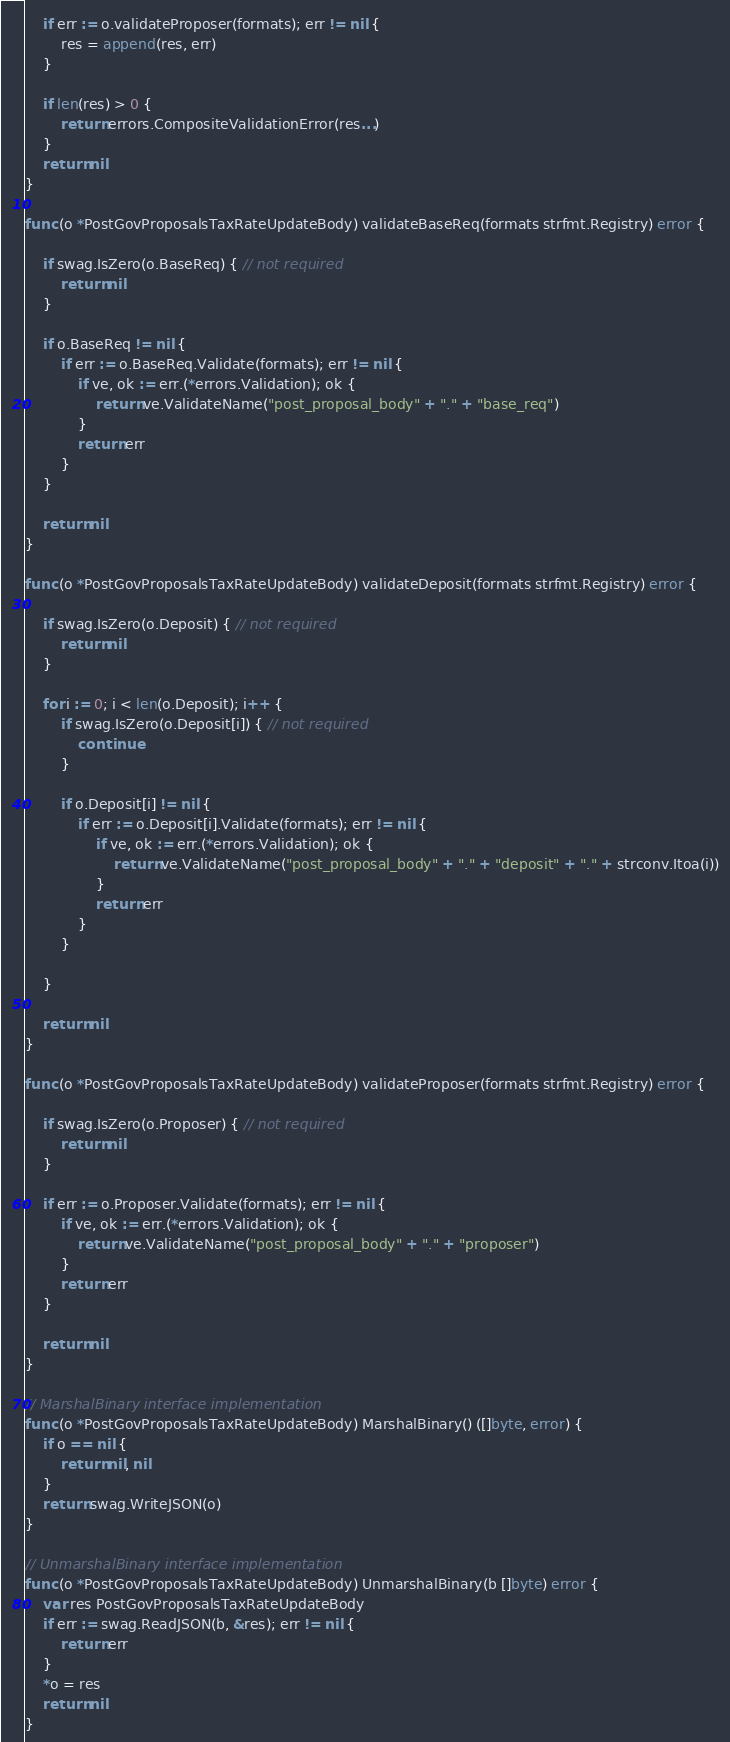<code> <loc_0><loc_0><loc_500><loc_500><_Go_>
	if err := o.validateProposer(formats); err != nil {
		res = append(res, err)
	}

	if len(res) > 0 {
		return errors.CompositeValidationError(res...)
	}
	return nil
}

func (o *PostGovProposalsTaxRateUpdateBody) validateBaseReq(formats strfmt.Registry) error {

	if swag.IsZero(o.BaseReq) { // not required
		return nil
	}

	if o.BaseReq != nil {
		if err := o.BaseReq.Validate(formats); err != nil {
			if ve, ok := err.(*errors.Validation); ok {
				return ve.ValidateName("post_proposal_body" + "." + "base_req")
			}
			return err
		}
	}

	return nil
}

func (o *PostGovProposalsTaxRateUpdateBody) validateDeposit(formats strfmt.Registry) error {

	if swag.IsZero(o.Deposit) { // not required
		return nil
	}

	for i := 0; i < len(o.Deposit); i++ {
		if swag.IsZero(o.Deposit[i]) { // not required
			continue
		}

		if o.Deposit[i] != nil {
			if err := o.Deposit[i].Validate(formats); err != nil {
				if ve, ok := err.(*errors.Validation); ok {
					return ve.ValidateName("post_proposal_body" + "." + "deposit" + "." + strconv.Itoa(i))
				}
				return err
			}
		}

	}

	return nil
}

func (o *PostGovProposalsTaxRateUpdateBody) validateProposer(formats strfmt.Registry) error {

	if swag.IsZero(o.Proposer) { // not required
		return nil
	}

	if err := o.Proposer.Validate(formats); err != nil {
		if ve, ok := err.(*errors.Validation); ok {
			return ve.ValidateName("post_proposal_body" + "." + "proposer")
		}
		return err
	}

	return nil
}

// MarshalBinary interface implementation
func (o *PostGovProposalsTaxRateUpdateBody) MarshalBinary() ([]byte, error) {
	if o == nil {
		return nil, nil
	}
	return swag.WriteJSON(o)
}

// UnmarshalBinary interface implementation
func (o *PostGovProposalsTaxRateUpdateBody) UnmarshalBinary(b []byte) error {
	var res PostGovProposalsTaxRateUpdateBody
	if err := swag.ReadJSON(b, &res); err != nil {
		return err
	}
	*o = res
	return nil
}
</code> 